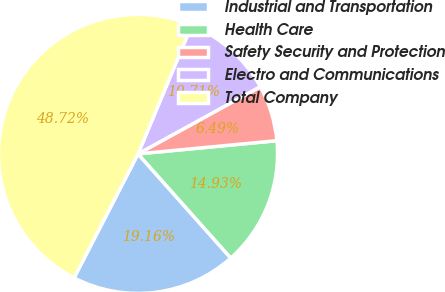Convert chart to OTSL. <chart><loc_0><loc_0><loc_500><loc_500><pie_chart><fcel>Industrial and Transportation<fcel>Health Care<fcel>Safety Security and Protection<fcel>Electro and Communications<fcel>Total Company<nl><fcel>19.16%<fcel>14.93%<fcel>6.49%<fcel>10.71%<fcel>48.72%<nl></chart> 